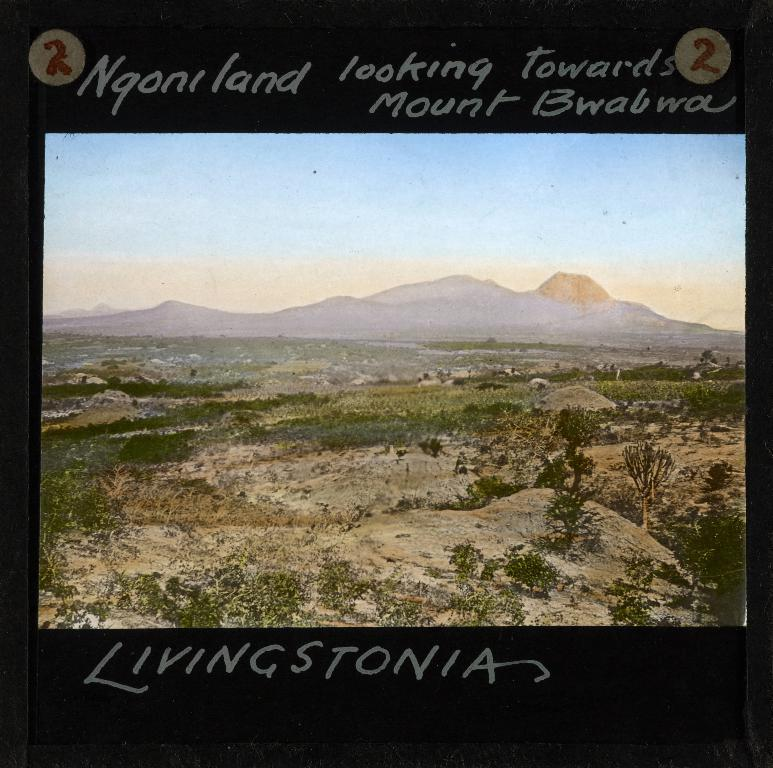<image>
Give a short and clear explanation of the subsequent image. Sign with land and mountains for Ngoniland mount bwabwa Livingstonia 